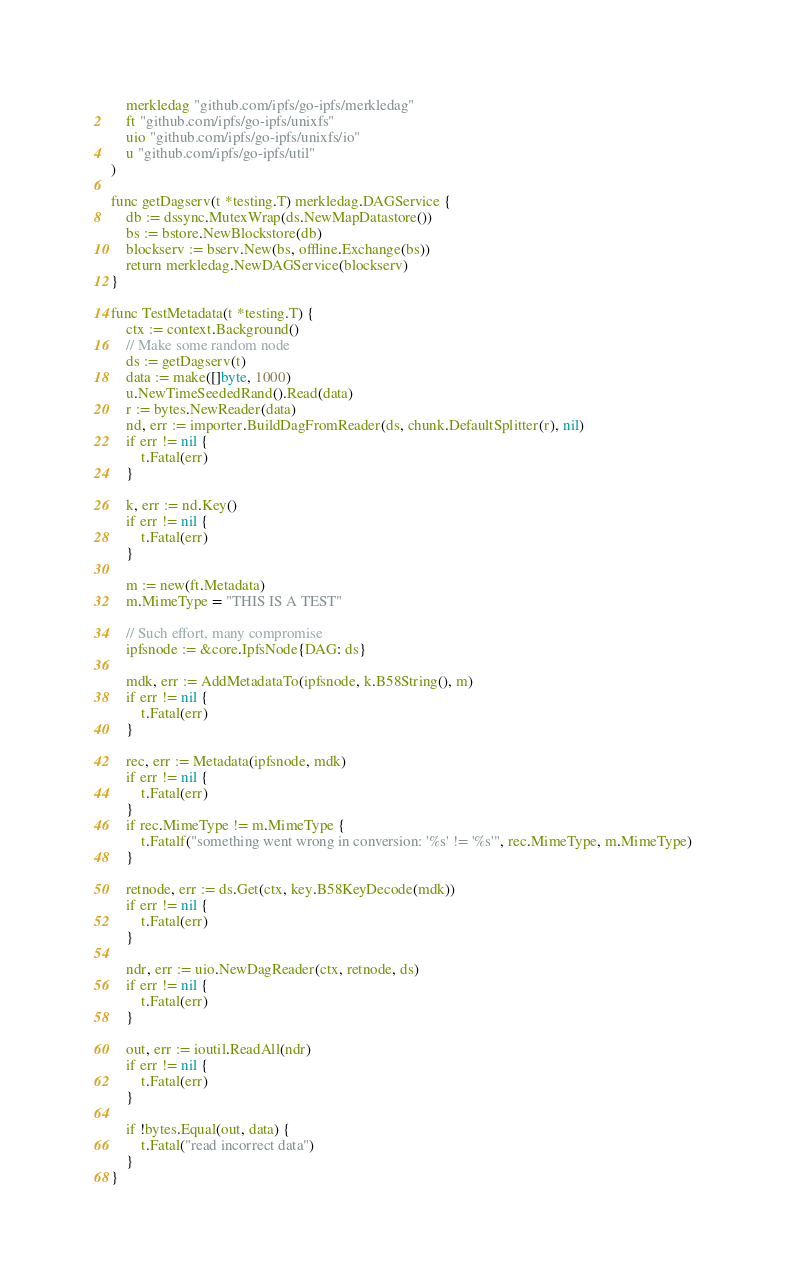Convert code to text. <code><loc_0><loc_0><loc_500><loc_500><_Go_>	merkledag "github.com/ipfs/go-ipfs/merkledag"
	ft "github.com/ipfs/go-ipfs/unixfs"
	uio "github.com/ipfs/go-ipfs/unixfs/io"
	u "github.com/ipfs/go-ipfs/util"
)

func getDagserv(t *testing.T) merkledag.DAGService {
	db := dssync.MutexWrap(ds.NewMapDatastore())
	bs := bstore.NewBlockstore(db)
	blockserv := bserv.New(bs, offline.Exchange(bs))
	return merkledag.NewDAGService(blockserv)
}

func TestMetadata(t *testing.T) {
	ctx := context.Background()
	// Make some random node
	ds := getDagserv(t)
	data := make([]byte, 1000)
	u.NewTimeSeededRand().Read(data)
	r := bytes.NewReader(data)
	nd, err := importer.BuildDagFromReader(ds, chunk.DefaultSplitter(r), nil)
	if err != nil {
		t.Fatal(err)
	}

	k, err := nd.Key()
	if err != nil {
		t.Fatal(err)
	}

	m := new(ft.Metadata)
	m.MimeType = "THIS IS A TEST"

	// Such effort, many compromise
	ipfsnode := &core.IpfsNode{DAG: ds}

	mdk, err := AddMetadataTo(ipfsnode, k.B58String(), m)
	if err != nil {
		t.Fatal(err)
	}

	rec, err := Metadata(ipfsnode, mdk)
	if err != nil {
		t.Fatal(err)
	}
	if rec.MimeType != m.MimeType {
		t.Fatalf("something went wrong in conversion: '%s' != '%s'", rec.MimeType, m.MimeType)
	}

	retnode, err := ds.Get(ctx, key.B58KeyDecode(mdk))
	if err != nil {
		t.Fatal(err)
	}

	ndr, err := uio.NewDagReader(ctx, retnode, ds)
	if err != nil {
		t.Fatal(err)
	}

	out, err := ioutil.ReadAll(ndr)
	if err != nil {
		t.Fatal(err)
	}

	if !bytes.Equal(out, data) {
		t.Fatal("read incorrect data")
	}
}
</code> 